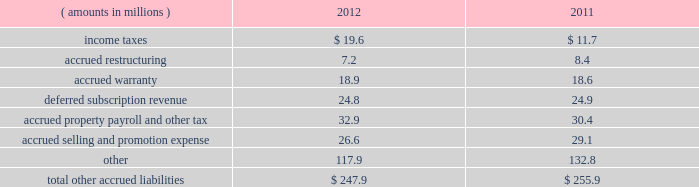Notes to consolidated financial statements ( continued ) management performs detailed reviews of its receivables on a monthly and/or quarterly basis to assess the adequacy of the allowances based on historical and current trends and other factors affecting credit losses and to determine if any impairment has occurred .
A receivable is impaired when it is probable that all amounts related to the receivable will not be collected according to the contractual terms of the agreement .
In circumstances where the company is aware of a specific customer 2019s inability to meet its financial obligations , a specific reserve is recorded against amounts due to reduce the net recognized receivable to the amount reasonably expected to be collected .
Additions to the allowances for doubtful accounts are maintained through adjustments to the provision for credit losses , which are charged to current period earnings ; amounts determined to be uncollectable are charged directly against the allowances , while amounts recovered on previously charged-off accounts increase the allowances .
Net charge-offs include the principal amount of losses charged off as well as charged-off interest and fees .
Recovered interest and fees previously charged-off are recorded through the allowances for doubtful accounts and increase the allowances .
Finance receivables are assessed for charge- off when an account becomes 120 days past due and are charged-off typically within 60 days of asset repossession .
Contract receivables related to equipment leases are generally charged-off when an account becomes 150 days past due , while contract receivables related to franchise finance and van leases are generally charged off up to 180 days past the asset return .
For finance and contract receivables , customer bankruptcies are generally charged-off upon notification that the associated debt is not being reaffirmed or , in any event , no later than 180 days past due .
Snap-on does not believe that its trade accounts , finance or contract receivables represent significant concentrations of credit risk because of the diversified portfolio of individual customers and geographical areas .
See note 3 for further information on receivables and allowances for doubtful accounts .
Other accrued liabilities : supplemental balance sheet information for 201cother accrued liabilities 201d as of 2012 and 2011 year end is as follows : ( amounts in millions ) 2012 2011 .
Inventories : snap-on values its inventory at the lower of cost or market and adjusts for the value of inventory that is estimated to be excess , obsolete or otherwise unmarketable .
Snap-on records allowances for excess and obsolete inventory based on historical and estimated future demand and market conditions .
Allowances for raw materials are largely based on an analysis of raw material age and actual physical inspection of raw material for fitness for use .
As part of evaluating the adequacy of allowances for work-in-progress and finished goods , management reviews individual product stock-keeping units ( skus ) by product category and product life cycle .
Cost adjustments for each product category/product life-cycle state are generally established and maintained based on a combination of historical experience , forecasted sales and promotions , technological obsolescence , inventory age and other actual known conditions and circumstances .
Should actual product marketability and raw material fitness for use be affected by conditions that are different from management estimates , further adjustments to inventory allowances may be required .
Snap-on adopted the 201clast-in , first-out 201d ( 201clifo 201d ) inventory valuation method in 1973 for its u.s .
Locations .
Snap-on 2019s u.s .
Inventories accounted for on a lifo basis consist of purchased product and inventory manufactured at the company 2019s heritage u.s .
Manufacturing facilities ( primarily hand tools and tool storage ) .
As snap-on began acquiring businesses in the 1990 2019s , the company retained the 201cfirst-in , first-out 201d ( 201cfifo 201d ) inventory valuation methodology used by the predecessor businesses prior to their acquisition by snap-on ; the company does not adopt the lifo inventory valuation methodology for new acquisitions .
See note 4 for further information on inventories .
72 snap-on incorporated .
What is the percentage change in the total other accrued liabilities from 2011 to 2012? 
Computations: ((247.9 - 255.9) / 255.9)
Answer: -0.03126. 